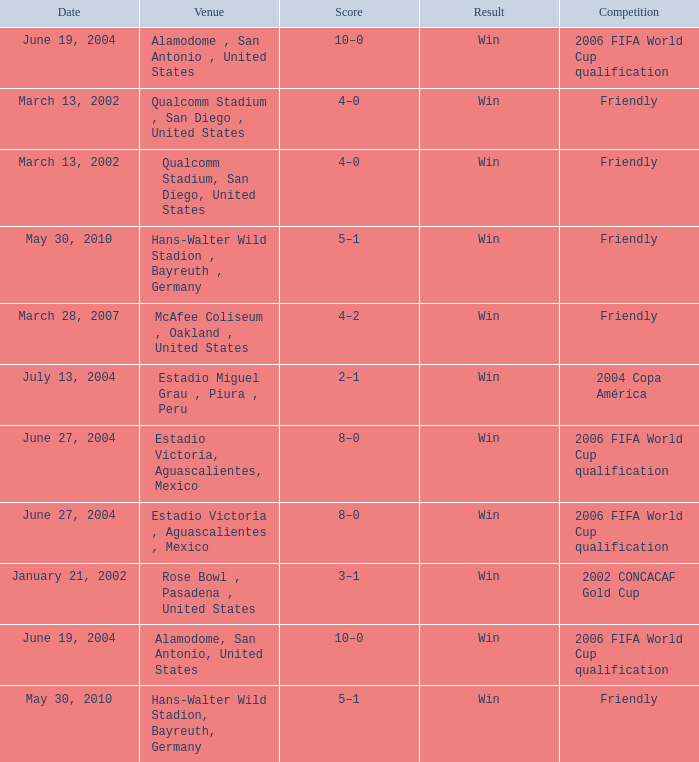What is the date of an event happening at the alamodome in san antonio, united states? June 19, 2004, June 19, 2004. 